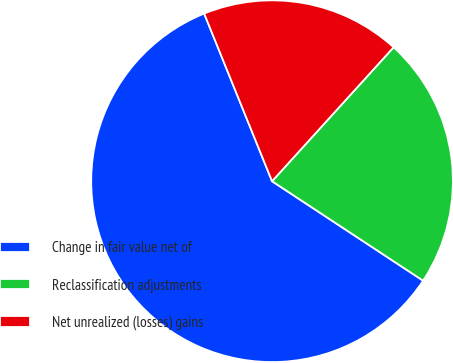Convert chart to OTSL. <chart><loc_0><loc_0><loc_500><loc_500><pie_chart><fcel>Change in fair value net of<fcel>Reclassification adjustments<fcel>Net unrealized (losses) gains<nl><fcel>59.61%<fcel>22.54%<fcel>17.85%<nl></chart> 